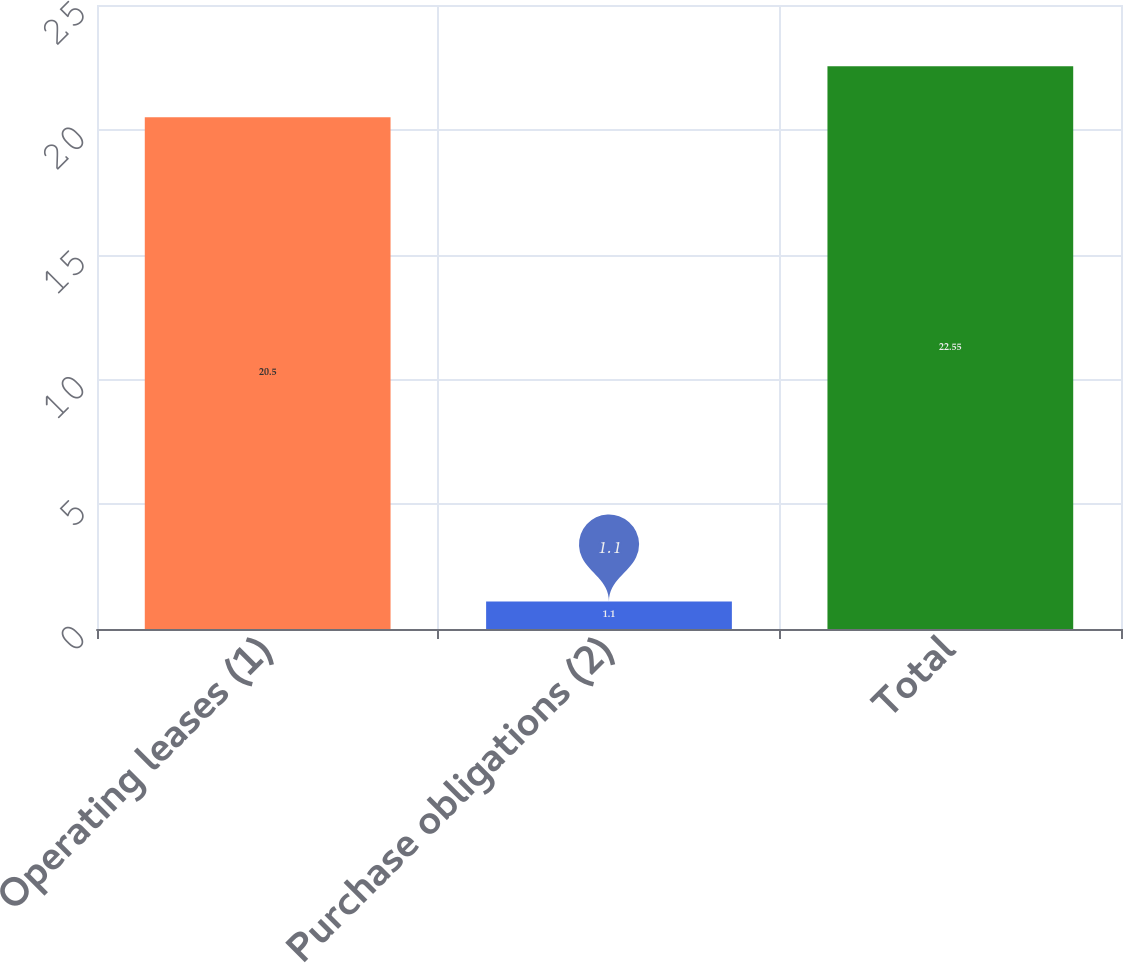<chart> <loc_0><loc_0><loc_500><loc_500><bar_chart><fcel>Operating leases (1)<fcel>Purchase obligations (2)<fcel>Total<nl><fcel>20.5<fcel>1.1<fcel>22.55<nl></chart> 